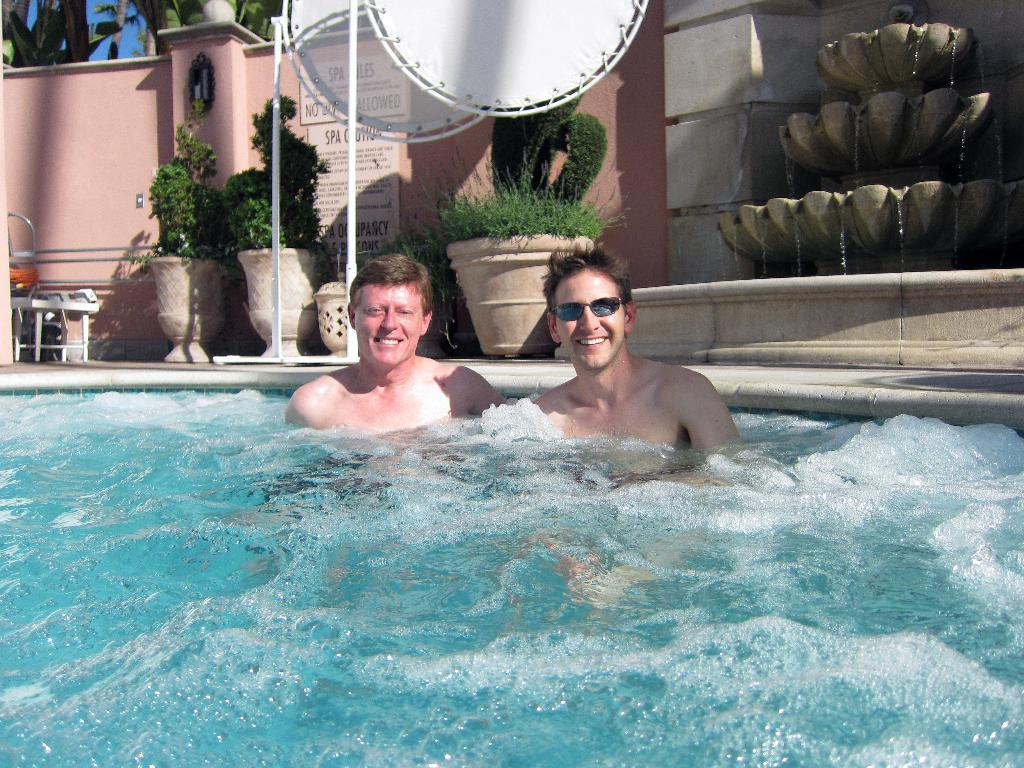How many men are in the image? There are two men in the image. What expression do the men have? The men are smiling. What can be seen in the image besides the men? There is water, boards, poles, plants with pots, a wall, and the sky visible in the image. What is present in the background of the image? The sky and leaves are present in the background of the image. What type of collar can be seen on the top of the image? There is no collar present in the image, and the top of the image is not mentioned in the provided facts. 